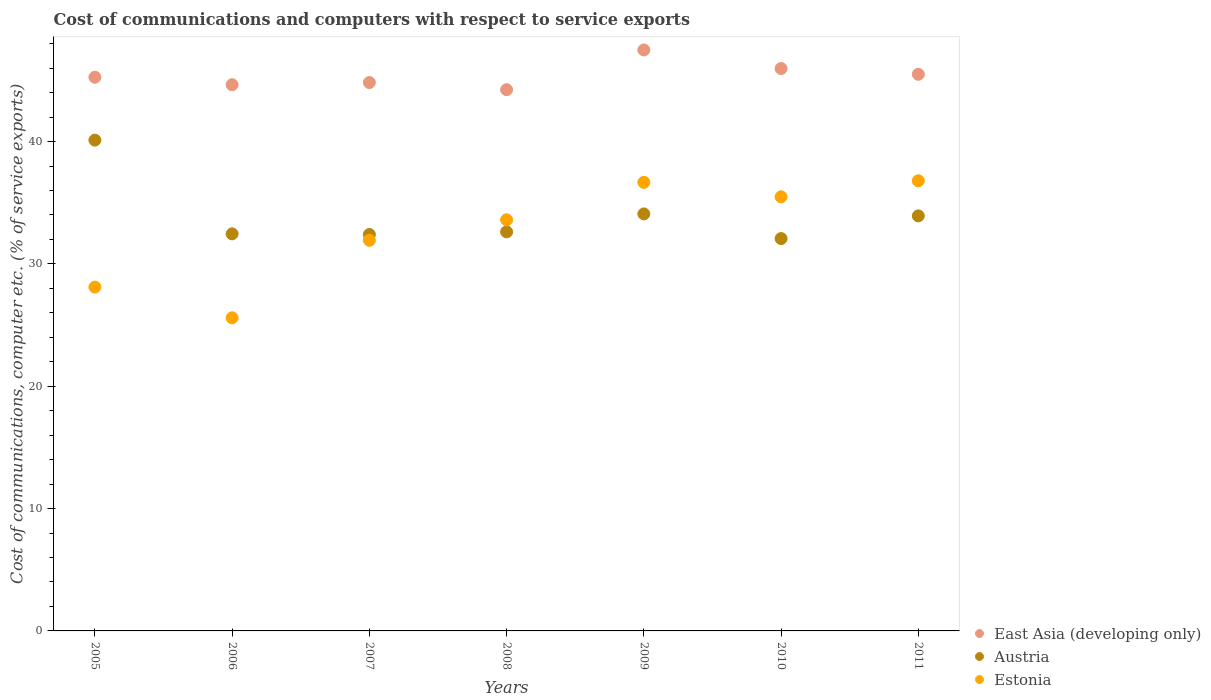How many different coloured dotlines are there?
Keep it short and to the point. 3. What is the cost of communications and computers in East Asia (developing only) in 2006?
Make the answer very short. 44.65. Across all years, what is the maximum cost of communications and computers in East Asia (developing only)?
Offer a terse response. 47.49. Across all years, what is the minimum cost of communications and computers in East Asia (developing only)?
Ensure brevity in your answer.  44.24. In which year was the cost of communications and computers in Estonia minimum?
Offer a terse response. 2006. What is the total cost of communications and computers in Estonia in the graph?
Provide a short and direct response. 228.19. What is the difference between the cost of communications and computers in Austria in 2006 and that in 2010?
Your response must be concise. 0.39. What is the difference between the cost of communications and computers in East Asia (developing only) in 2010 and the cost of communications and computers in Austria in 2007?
Your answer should be compact. 13.56. What is the average cost of communications and computers in Estonia per year?
Provide a short and direct response. 32.6. In the year 2010, what is the difference between the cost of communications and computers in East Asia (developing only) and cost of communications and computers in Estonia?
Make the answer very short. 10.49. In how many years, is the cost of communications and computers in Estonia greater than 18 %?
Your answer should be very brief. 7. What is the ratio of the cost of communications and computers in East Asia (developing only) in 2007 to that in 2010?
Ensure brevity in your answer.  0.98. Is the cost of communications and computers in Austria in 2006 less than that in 2007?
Ensure brevity in your answer.  No. Is the difference between the cost of communications and computers in East Asia (developing only) in 2008 and 2009 greater than the difference between the cost of communications and computers in Estonia in 2008 and 2009?
Your response must be concise. No. What is the difference between the highest and the second highest cost of communications and computers in East Asia (developing only)?
Your answer should be very brief. 1.52. What is the difference between the highest and the lowest cost of communications and computers in Estonia?
Your response must be concise. 11.2. Is the cost of communications and computers in Estonia strictly less than the cost of communications and computers in East Asia (developing only) over the years?
Your answer should be compact. Yes. How many dotlines are there?
Ensure brevity in your answer.  3. How many years are there in the graph?
Keep it short and to the point. 7. What is the difference between two consecutive major ticks on the Y-axis?
Your response must be concise. 10. How many legend labels are there?
Your answer should be very brief. 3. How are the legend labels stacked?
Provide a succinct answer. Vertical. What is the title of the graph?
Keep it short and to the point. Cost of communications and computers with respect to service exports. What is the label or title of the Y-axis?
Give a very brief answer. Cost of communications, computer etc. (% of service exports). What is the Cost of communications, computer etc. (% of service exports) of East Asia (developing only) in 2005?
Keep it short and to the point. 45.26. What is the Cost of communications, computer etc. (% of service exports) in Austria in 2005?
Provide a short and direct response. 40.12. What is the Cost of communications, computer etc. (% of service exports) of Estonia in 2005?
Offer a terse response. 28.11. What is the Cost of communications, computer etc. (% of service exports) of East Asia (developing only) in 2006?
Offer a terse response. 44.65. What is the Cost of communications, computer etc. (% of service exports) in Austria in 2006?
Keep it short and to the point. 32.46. What is the Cost of communications, computer etc. (% of service exports) of Estonia in 2006?
Offer a very short reply. 25.59. What is the Cost of communications, computer etc. (% of service exports) in East Asia (developing only) in 2007?
Your answer should be very brief. 44.83. What is the Cost of communications, computer etc. (% of service exports) of Austria in 2007?
Provide a short and direct response. 32.41. What is the Cost of communications, computer etc. (% of service exports) in Estonia in 2007?
Offer a terse response. 31.93. What is the Cost of communications, computer etc. (% of service exports) in East Asia (developing only) in 2008?
Provide a succinct answer. 44.24. What is the Cost of communications, computer etc. (% of service exports) in Austria in 2008?
Offer a very short reply. 32.62. What is the Cost of communications, computer etc. (% of service exports) in Estonia in 2008?
Provide a short and direct response. 33.61. What is the Cost of communications, computer etc. (% of service exports) of East Asia (developing only) in 2009?
Offer a terse response. 47.49. What is the Cost of communications, computer etc. (% of service exports) in Austria in 2009?
Ensure brevity in your answer.  34.09. What is the Cost of communications, computer etc. (% of service exports) of Estonia in 2009?
Your answer should be compact. 36.67. What is the Cost of communications, computer etc. (% of service exports) of East Asia (developing only) in 2010?
Provide a short and direct response. 45.97. What is the Cost of communications, computer etc. (% of service exports) in Austria in 2010?
Offer a terse response. 32.07. What is the Cost of communications, computer etc. (% of service exports) in Estonia in 2010?
Your answer should be very brief. 35.49. What is the Cost of communications, computer etc. (% of service exports) in East Asia (developing only) in 2011?
Your answer should be compact. 45.5. What is the Cost of communications, computer etc. (% of service exports) of Austria in 2011?
Keep it short and to the point. 33.93. What is the Cost of communications, computer etc. (% of service exports) in Estonia in 2011?
Ensure brevity in your answer.  36.8. Across all years, what is the maximum Cost of communications, computer etc. (% of service exports) in East Asia (developing only)?
Keep it short and to the point. 47.49. Across all years, what is the maximum Cost of communications, computer etc. (% of service exports) in Austria?
Provide a succinct answer. 40.12. Across all years, what is the maximum Cost of communications, computer etc. (% of service exports) of Estonia?
Keep it short and to the point. 36.8. Across all years, what is the minimum Cost of communications, computer etc. (% of service exports) of East Asia (developing only)?
Offer a terse response. 44.24. Across all years, what is the minimum Cost of communications, computer etc. (% of service exports) of Austria?
Provide a short and direct response. 32.07. Across all years, what is the minimum Cost of communications, computer etc. (% of service exports) in Estonia?
Give a very brief answer. 25.59. What is the total Cost of communications, computer etc. (% of service exports) in East Asia (developing only) in the graph?
Provide a short and direct response. 317.95. What is the total Cost of communications, computer etc. (% of service exports) of Austria in the graph?
Make the answer very short. 237.69. What is the total Cost of communications, computer etc. (% of service exports) in Estonia in the graph?
Ensure brevity in your answer.  228.19. What is the difference between the Cost of communications, computer etc. (% of service exports) of East Asia (developing only) in 2005 and that in 2006?
Ensure brevity in your answer.  0.61. What is the difference between the Cost of communications, computer etc. (% of service exports) of Austria in 2005 and that in 2006?
Your answer should be compact. 7.66. What is the difference between the Cost of communications, computer etc. (% of service exports) in Estonia in 2005 and that in 2006?
Offer a terse response. 2.51. What is the difference between the Cost of communications, computer etc. (% of service exports) in East Asia (developing only) in 2005 and that in 2007?
Provide a succinct answer. 0.44. What is the difference between the Cost of communications, computer etc. (% of service exports) in Austria in 2005 and that in 2007?
Ensure brevity in your answer.  7.71. What is the difference between the Cost of communications, computer etc. (% of service exports) of Estonia in 2005 and that in 2007?
Offer a terse response. -3.83. What is the difference between the Cost of communications, computer etc. (% of service exports) in East Asia (developing only) in 2005 and that in 2008?
Offer a terse response. 1.02. What is the difference between the Cost of communications, computer etc. (% of service exports) of Austria in 2005 and that in 2008?
Give a very brief answer. 7.5. What is the difference between the Cost of communications, computer etc. (% of service exports) of Estonia in 2005 and that in 2008?
Your answer should be very brief. -5.5. What is the difference between the Cost of communications, computer etc. (% of service exports) in East Asia (developing only) in 2005 and that in 2009?
Your answer should be compact. -2.23. What is the difference between the Cost of communications, computer etc. (% of service exports) in Austria in 2005 and that in 2009?
Your response must be concise. 6.03. What is the difference between the Cost of communications, computer etc. (% of service exports) of Estonia in 2005 and that in 2009?
Offer a very short reply. -8.56. What is the difference between the Cost of communications, computer etc. (% of service exports) in East Asia (developing only) in 2005 and that in 2010?
Your answer should be compact. -0.71. What is the difference between the Cost of communications, computer etc. (% of service exports) in Austria in 2005 and that in 2010?
Provide a short and direct response. 8.05. What is the difference between the Cost of communications, computer etc. (% of service exports) in Estonia in 2005 and that in 2010?
Your response must be concise. -7.38. What is the difference between the Cost of communications, computer etc. (% of service exports) in East Asia (developing only) in 2005 and that in 2011?
Give a very brief answer. -0.24. What is the difference between the Cost of communications, computer etc. (% of service exports) of Austria in 2005 and that in 2011?
Offer a very short reply. 6.19. What is the difference between the Cost of communications, computer etc. (% of service exports) of Estonia in 2005 and that in 2011?
Provide a short and direct response. -8.69. What is the difference between the Cost of communications, computer etc. (% of service exports) in East Asia (developing only) in 2006 and that in 2007?
Make the answer very short. -0.18. What is the difference between the Cost of communications, computer etc. (% of service exports) of Austria in 2006 and that in 2007?
Your answer should be very brief. 0.05. What is the difference between the Cost of communications, computer etc. (% of service exports) of Estonia in 2006 and that in 2007?
Your answer should be very brief. -6.34. What is the difference between the Cost of communications, computer etc. (% of service exports) in East Asia (developing only) in 2006 and that in 2008?
Your answer should be very brief. 0.41. What is the difference between the Cost of communications, computer etc. (% of service exports) of Austria in 2006 and that in 2008?
Offer a very short reply. -0.16. What is the difference between the Cost of communications, computer etc. (% of service exports) of Estonia in 2006 and that in 2008?
Keep it short and to the point. -8.02. What is the difference between the Cost of communications, computer etc. (% of service exports) of East Asia (developing only) in 2006 and that in 2009?
Offer a very short reply. -2.84. What is the difference between the Cost of communications, computer etc. (% of service exports) of Austria in 2006 and that in 2009?
Give a very brief answer. -1.63. What is the difference between the Cost of communications, computer etc. (% of service exports) in Estonia in 2006 and that in 2009?
Keep it short and to the point. -11.07. What is the difference between the Cost of communications, computer etc. (% of service exports) in East Asia (developing only) in 2006 and that in 2010?
Offer a terse response. -1.32. What is the difference between the Cost of communications, computer etc. (% of service exports) of Austria in 2006 and that in 2010?
Offer a terse response. 0.39. What is the difference between the Cost of communications, computer etc. (% of service exports) in Estonia in 2006 and that in 2010?
Offer a very short reply. -9.89. What is the difference between the Cost of communications, computer etc. (% of service exports) in East Asia (developing only) in 2006 and that in 2011?
Ensure brevity in your answer.  -0.85. What is the difference between the Cost of communications, computer etc. (% of service exports) in Austria in 2006 and that in 2011?
Offer a terse response. -1.47. What is the difference between the Cost of communications, computer etc. (% of service exports) in Estonia in 2006 and that in 2011?
Your response must be concise. -11.2. What is the difference between the Cost of communications, computer etc. (% of service exports) of East Asia (developing only) in 2007 and that in 2008?
Provide a succinct answer. 0.58. What is the difference between the Cost of communications, computer etc. (% of service exports) of Austria in 2007 and that in 2008?
Your response must be concise. -0.21. What is the difference between the Cost of communications, computer etc. (% of service exports) of Estonia in 2007 and that in 2008?
Offer a terse response. -1.68. What is the difference between the Cost of communications, computer etc. (% of service exports) in East Asia (developing only) in 2007 and that in 2009?
Keep it short and to the point. -2.66. What is the difference between the Cost of communications, computer etc. (% of service exports) in Austria in 2007 and that in 2009?
Give a very brief answer. -1.68. What is the difference between the Cost of communications, computer etc. (% of service exports) in Estonia in 2007 and that in 2009?
Keep it short and to the point. -4.73. What is the difference between the Cost of communications, computer etc. (% of service exports) in East Asia (developing only) in 2007 and that in 2010?
Give a very brief answer. -1.14. What is the difference between the Cost of communications, computer etc. (% of service exports) of Austria in 2007 and that in 2010?
Provide a succinct answer. 0.34. What is the difference between the Cost of communications, computer etc. (% of service exports) in Estonia in 2007 and that in 2010?
Provide a short and direct response. -3.55. What is the difference between the Cost of communications, computer etc. (% of service exports) in East Asia (developing only) in 2007 and that in 2011?
Make the answer very short. -0.67. What is the difference between the Cost of communications, computer etc. (% of service exports) in Austria in 2007 and that in 2011?
Provide a short and direct response. -1.52. What is the difference between the Cost of communications, computer etc. (% of service exports) in Estonia in 2007 and that in 2011?
Make the answer very short. -4.86. What is the difference between the Cost of communications, computer etc. (% of service exports) of East Asia (developing only) in 2008 and that in 2009?
Provide a short and direct response. -3.25. What is the difference between the Cost of communications, computer etc. (% of service exports) of Austria in 2008 and that in 2009?
Provide a short and direct response. -1.47. What is the difference between the Cost of communications, computer etc. (% of service exports) of Estonia in 2008 and that in 2009?
Offer a terse response. -3.06. What is the difference between the Cost of communications, computer etc. (% of service exports) of East Asia (developing only) in 2008 and that in 2010?
Give a very brief answer. -1.73. What is the difference between the Cost of communications, computer etc. (% of service exports) in Austria in 2008 and that in 2010?
Ensure brevity in your answer.  0.55. What is the difference between the Cost of communications, computer etc. (% of service exports) in Estonia in 2008 and that in 2010?
Offer a very short reply. -1.88. What is the difference between the Cost of communications, computer etc. (% of service exports) in East Asia (developing only) in 2008 and that in 2011?
Make the answer very short. -1.26. What is the difference between the Cost of communications, computer etc. (% of service exports) in Austria in 2008 and that in 2011?
Your response must be concise. -1.31. What is the difference between the Cost of communications, computer etc. (% of service exports) in Estonia in 2008 and that in 2011?
Your answer should be very brief. -3.19. What is the difference between the Cost of communications, computer etc. (% of service exports) of East Asia (developing only) in 2009 and that in 2010?
Provide a short and direct response. 1.52. What is the difference between the Cost of communications, computer etc. (% of service exports) of Austria in 2009 and that in 2010?
Offer a terse response. 2.02. What is the difference between the Cost of communications, computer etc. (% of service exports) of Estonia in 2009 and that in 2010?
Provide a succinct answer. 1.18. What is the difference between the Cost of communications, computer etc. (% of service exports) in East Asia (developing only) in 2009 and that in 2011?
Keep it short and to the point. 1.99. What is the difference between the Cost of communications, computer etc. (% of service exports) of Austria in 2009 and that in 2011?
Offer a very short reply. 0.16. What is the difference between the Cost of communications, computer etc. (% of service exports) of Estonia in 2009 and that in 2011?
Give a very brief answer. -0.13. What is the difference between the Cost of communications, computer etc. (% of service exports) of East Asia (developing only) in 2010 and that in 2011?
Offer a terse response. 0.47. What is the difference between the Cost of communications, computer etc. (% of service exports) in Austria in 2010 and that in 2011?
Offer a terse response. -1.86. What is the difference between the Cost of communications, computer etc. (% of service exports) of Estonia in 2010 and that in 2011?
Provide a succinct answer. -1.31. What is the difference between the Cost of communications, computer etc. (% of service exports) of East Asia (developing only) in 2005 and the Cost of communications, computer etc. (% of service exports) of Austria in 2006?
Give a very brief answer. 12.8. What is the difference between the Cost of communications, computer etc. (% of service exports) of East Asia (developing only) in 2005 and the Cost of communications, computer etc. (% of service exports) of Estonia in 2006?
Keep it short and to the point. 19.67. What is the difference between the Cost of communications, computer etc. (% of service exports) in Austria in 2005 and the Cost of communications, computer etc. (% of service exports) in Estonia in 2006?
Keep it short and to the point. 14.53. What is the difference between the Cost of communications, computer etc. (% of service exports) of East Asia (developing only) in 2005 and the Cost of communications, computer etc. (% of service exports) of Austria in 2007?
Offer a very short reply. 12.86. What is the difference between the Cost of communications, computer etc. (% of service exports) of East Asia (developing only) in 2005 and the Cost of communications, computer etc. (% of service exports) of Estonia in 2007?
Your answer should be compact. 13.33. What is the difference between the Cost of communications, computer etc. (% of service exports) in Austria in 2005 and the Cost of communications, computer etc. (% of service exports) in Estonia in 2007?
Keep it short and to the point. 8.19. What is the difference between the Cost of communications, computer etc. (% of service exports) in East Asia (developing only) in 2005 and the Cost of communications, computer etc. (% of service exports) in Austria in 2008?
Ensure brevity in your answer.  12.64. What is the difference between the Cost of communications, computer etc. (% of service exports) in East Asia (developing only) in 2005 and the Cost of communications, computer etc. (% of service exports) in Estonia in 2008?
Your answer should be compact. 11.65. What is the difference between the Cost of communications, computer etc. (% of service exports) in Austria in 2005 and the Cost of communications, computer etc. (% of service exports) in Estonia in 2008?
Provide a short and direct response. 6.51. What is the difference between the Cost of communications, computer etc. (% of service exports) of East Asia (developing only) in 2005 and the Cost of communications, computer etc. (% of service exports) of Austria in 2009?
Your answer should be very brief. 11.17. What is the difference between the Cost of communications, computer etc. (% of service exports) of East Asia (developing only) in 2005 and the Cost of communications, computer etc. (% of service exports) of Estonia in 2009?
Give a very brief answer. 8.6. What is the difference between the Cost of communications, computer etc. (% of service exports) in Austria in 2005 and the Cost of communications, computer etc. (% of service exports) in Estonia in 2009?
Keep it short and to the point. 3.45. What is the difference between the Cost of communications, computer etc. (% of service exports) of East Asia (developing only) in 2005 and the Cost of communications, computer etc. (% of service exports) of Austria in 2010?
Your response must be concise. 13.19. What is the difference between the Cost of communications, computer etc. (% of service exports) of East Asia (developing only) in 2005 and the Cost of communications, computer etc. (% of service exports) of Estonia in 2010?
Ensure brevity in your answer.  9.78. What is the difference between the Cost of communications, computer etc. (% of service exports) of Austria in 2005 and the Cost of communications, computer etc. (% of service exports) of Estonia in 2010?
Offer a very short reply. 4.63. What is the difference between the Cost of communications, computer etc. (% of service exports) in East Asia (developing only) in 2005 and the Cost of communications, computer etc. (% of service exports) in Austria in 2011?
Offer a terse response. 11.34. What is the difference between the Cost of communications, computer etc. (% of service exports) of East Asia (developing only) in 2005 and the Cost of communications, computer etc. (% of service exports) of Estonia in 2011?
Ensure brevity in your answer.  8.47. What is the difference between the Cost of communications, computer etc. (% of service exports) of Austria in 2005 and the Cost of communications, computer etc. (% of service exports) of Estonia in 2011?
Provide a short and direct response. 3.32. What is the difference between the Cost of communications, computer etc. (% of service exports) in East Asia (developing only) in 2006 and the Cost of communications, computer etc. (% of service exports) in Austria in 2007?
Your response must be concise. 12.24. What is the difference between the Cost of communications, computer etc. (% of service exports) in East Asia (developing only) in 2006 and the Cost of communications, computer etc. (% of service exports) in Estonia in 2007?
Make the answer very short. 12.72. What is the difference between the Cost of communications, computer etc. (% of service exports) of Austria in 2006 and the Cost of communications, computer etc. (% of service exports) of Estonia in 2007?
Offer a terse response. 0.53. What is the difference between the Cost of communications, computer etc. (% of service exports) in East Asia (developing only) in 2006 and the Cost of communications, computer etc. (% of service exports) in Austria in 2008?
Your response must be concise. 12.03. What is the difference between the Cost of communications, computer etc. (% of service exports) of East Asia (developing only) in 2006 and the Cost of communications, computer etc. (% of service exports) of Estonia in 2008?
Keep it short and to the point. 11.04. What is the difference between the Cost of communications, computer etc. (% of service exports) of Austria in 2006 and the Cost of communications, computer etc. (% of service exports) of Estonia in 2008?
Ensure brevity in your answer.  -1.15. What is the difference between the Cost of communications, computer etc. (% of service exports) in East Asia (developing only) in 2006 and the Cost of communications, computer etc. (% of service exports) in Austria in 2009?
Your response must be concise. 10.56. What is the difference between the Cost of communications, computer etc. (% of service exports) of East Asia (developing only) in 2006 and the Cost of communications, computer etc. (% of service exports) of Estonia in 2009?
Provide a short and direct response. 7.98. What is the difference between the Cost of communications, computer etc. (% of service exports) of Austria in 2006 and the Cost of communications, computer etc. (% of service exports) of Estonia in 2009?
Offer a very short reply. -4.21. What is the difference between the Cost of communications, computer etc. (% of service exports) of East Asia (developing only) in 2006 and the Cost of communications, computer etc. (% of service exports) of Austria in 2010?
Keep it short and to the point. 12.58. What is the difference between the Cost of communications, computer etc. (% of service exports) in East Asia (developing only) in 2006 and the Cost of communications, computer etc. (% of service exports) in Estonia in 2010?
Your answer should be very brief. 9.16. What is the difference between the Cost of communications, computer etc. (% of service exports) of Austria in 2006 and the Cost of communications, computer etc. (% of service exports) of Estonia in 2010?
Give a very brief answer. -3.03. What is the difference between the Cost of communications, computer etc. (% of service exports) of East Asia (developing only) in 2006 and the Cost of communications, computer etc. (% of service exports) of Austria in 2011?
Your answer should be very brief. 10.72. What is the difference between the Cost of communications, computer etc. (% of service exports) in East Asia (developing only) in 2006 and the Cost of communications, computer etc. (% of service exports) in Estonia in 2011?
Your answer should be very brief. 7.85. What is the difference between the Cost of communications, computer etc. (% of service exports) of Austria in 2006 and the Cost of communications, computer etc. (% of service exports) of Estonia in 2011?
Provide a short and direct response. -4.34. What is the difference between the Cost of communications, computer etc. (% of service exports) of East Asia (developing only) in 2007 and the Cost of communications, computer etc. (% of service exports) of Austria in 2008?
Offer a terse response. 12.21. What is the difference between the Cost of communications, computer etc. (% of service exports) in East Asia (developing only) in 2007 and the Cost of communications, computer etc. (% of service exports) in Estonia in 2008?
Your answer should be compact. 11.22. What is the difference between the Cost of communications, computer etc. (% of service exports) of Austria in 2007 and the Cost of communications, computer etc. (% of service exports) of Estonia in 2008?
Provide a succinct answer. -1.2. What is the difference between the Cost of communications, computer etc. (% of service exports) of East Asia (developing only) in 2007 and the Cost of communications, computer etc. (% of service exports) of Austria in 2009?
Provide a short and direct response. 10.74. What is the difference between the Cost of communications, computer etc. (% of service exports) of East Asia (developing only) in 2007 and the Cost of communications, computer etc. (% of service exports) of Estonia in 2009?
Provide a succinct answer. 8.16. What is the difference between the Cost of communications, computer etc. (% of service exports) of Austria in 2007 and the Cost of communications, computer etc. (% of service exports) of Estonia in 2009?
Your answer should be compact. -4.26. What is the difference between the Cost of communications, computer etc. (% of service exports) of East Asia (developing only) in 2007 and the Cost of communications, computer etc. (% of service exports) of Austria in 2010?
Provide a short and direct response. 12.76. What is the difference between the Cost of communications, computer etc. (% of service exports) in East Asia (developing only) in 2007 and the Cost of communications, computer etc. (% of service exports) in Estonia in 2010?
Make the answer very short. 9.34. What is the difference between the Cost of communications, computer etc. (% of service exports) of Austria in 2007 and the Cost of communications, computer etc. (% of service exports) of Estonia in 2010?
Give a very brief answer. -3.08. What is the difference between the Cost of communications, computer etc. (% of service exports) of East Asia (developing only) in 2007 and the Cost of communications, computer etc. (% of service exports) of Austria in 2011?
Your response must be concise. 10.9. What is the difference between the Cost of communications, computer etc. (% of service exports) of East Asia (developing only) in 2007 and the Cost of communications, computer etc. (% of service exports) of Estonia in 2011?
Provide a short and direct response. 8.03. What is the difference between the Cost of communications, computer etc. (% of service exports) of Austria in 2007 and the Cost of communications, computer etc. (% of service exports) of Estonia in 2011?
Offer a terse response. -4.39. What is the difference between the Cost of communications, computer etc. (% of service exports) of East Asia (developing only) in 2008 and the Cost of communications, computer etc. (% of service exports) of Austria in 2009?
Make the answer very short. 10.16. What is the difference between the Cost of communications, computer etc. (% of service exports) in East Asia (developing only) in 2008 and the Cost of communications, computer etc. (% of service exports) in Estonia in 2009?
Ensure brevity in your answer.  7.58. What is the difference between the Cost of communications, computer etc. (% of service exports) of Austria in 2008 and the Cost of communications, computer etc. (% of service exports) of Estonia in 2009?
Your answer should be compact. -4.05. What is the difference between the Cost of communications, computer etc. (% of service exports) in East Asia (developing only) in 2008 and the Cost of communications, computer etc. (% of service exports) in Austria in 2010?
Keep it short and to the point. 12.17. What is the difference between the Cost of communications, computer etc. (% of service exports) in East Asia (developing only) in 2008 and the Cost of communications, computer etc. (% of service exports) in Estonia in 2010?
Make the answer very short. 8.76. What is the difference between the Cost of communications, computer etc. (% of service exports) in Austria in 2008 and the Cost of communications, computer etc. (% of service exports) in Estonia in 2010?
Give a very brief answer. -2.87. What is the difference between the Cost of communications, computer etc. (% of service exports) of East Asia (developing only) in 2008 and the Cost of communications, computer etc. (% of service exports) of Austria in 2011?
Keep it short and to the point. 10.32. What is the difference between the Cost of communications, computer etc. (% of service exports) of East Asia (developing only) in 2008 and the Cost of communications, computer etc. (% of service exports) of Estonia in 2011?
Ensure brevity in your answer.  7.45. What is the difference between the Cost of communications, computer etc. (% of service exports) of Austria in 2008 and the Cost of communications, computer etc. (% of service exports) of Estonia in 2011?
Give a very brief answer. -4.18. What is the difference between the Cost of communications, computer etc. (% of service exports) of East Asia (developing only) in 2009 and the Cost of communications, computer etc. (% of service exports) of Austria in 2010?
Give a very brief answer. 15.42. What is the difference between the Cost of communications, computer etc. (% of service exports) of East Asia (developing only) in 2009 and the Cost of communications, computer etc. (% of service exports) of Estonia in 2010?
Ensure brevity in your answer.  12. What is the difference between the Cost of communications, computer etc. (% of service exports) of Austria in 2009 and the Cost of communications, computer etc. (% of service exports) of Estonia in 2010?
Your answer should be very brief. -1.4. What is the difference between the Cost of communications, computer etc. (% of service exports) in East Asia (developing only) in 2009 and the Cost of communications, computer etc. (% of service exports) in Austria in 2011?
Keep it short and to the point. 13.56. What is the difference between the Cost of communications, computer etc. (% of service exports) of East Asia (developing only) in 2009 and the Cost of communications, computer etc. (% of service exports) of Estonia in 2011?
Give a very brief answer. 10.69. What is the difference between the Cost of communications, computer etc. (% of service exports) in Austria in 2009 and the Cost of communications, computer etc. (% of service exports) in Estonia in 2011?
Provide a short and direct response. -2.71. What is the difference between the Cost of communications, computer etc. (% of service exports) in East Asia (developing only) in 2010 and the Cost of communications, computer etc. (% of service exports) in Austria in 2011?
Give a very brief answer. 12.05. What is the difference between the Cost of communications, computer etc. (% of service exports) of East Asia (developing only) in 2010 and the Cost of communications, computer etc. (% of service exports) of Estonia in 2011?
Provide a short and direct response. 9.18. What is the difference between the Cost of communications, computer etc. (% of service exports) in Austria in 2010 and the Cost of communications, computer etc. (% of service exports) in Estonia in 2011?
Give a very brief answer. -4.72. What is the average Cost of communications, computer etc. (% of service exports) of East Asia (developing only) per year?
Your answer should be very brief. 45.42. What is the average Cost of communications, computer etc. (% of service exports) in Austria per year?
Your answer should be very brief. 33.96. What is the average Cost of communications, computer etc. (% of service exports) in Estonia per year?
Offer a terse response. 32.6. In the year 2005, what is the difference between the Cost of communications, computer etc. (% of service exports) of East Asia (developing only) and Cost of communications, computer etc. (% of service exports) of Austria?
Your answer should be compact. 5.14. In the year 2005, what is the difference between the Cost of communications, computer etc. (% of service exports) in East Asia (developing only) and Cost of communications, computer etc. (% of service exports) in Estonia?
Your answer should be compact. 17.16. In the year 2005, what is the difference between the Cost of communications, computer etc. (% of service exports) of Austria and Cost of communications, computer etc. (% of service exports) of Estonia?
Your answer should be very brief. 12.01. In the year 2006, what is the difference between the Cost of communications, computer etc. (% of service exports) in East Asia (developing only) and Cost of communications, computer etc. (% of service exports) in Austria?
Keep it short and to the point. 12.19. In the year 2006, what is the difference between the Cost of communications, computer etc. (% of service exports) in East Asia (developing only) and Cost of communications, computer etc. (% of service exports) in Estonia?
Provide a short and direct response. 19.06. In the year 2006, what is the difference between the Cost of communications, computer etc. (% of service exports) in Austria and Cost of communications, computer etc. (% of service exports) in Estonia?
Offer a very short reply. 6.87. In the year 2007, what is the difference between the Cost of communications, computer etc. (% of service exports) in East Asia (developing only) and Cost of communications, computer etc. (% of service exports) in Austria?
Keep it short and to the point. 12.42. In the year 2007, what is the difference between the Cost of communications, computer etc. (% of service exports) in East Asia (developing only) and Cost of communications, computer etc. (% of service exports) in Estonia?
Offer a very short reply. 12.89. In the year 2007, what is the difference between the Cost of communications, computer etc. (% of service exports) in Austria and Cost of communications, computer etc. (% of service exports) in Estonia?
Ensure brevity in your answer.  0.47. In the year 2008, what is the difference between the Cost of communications, computer etc. (% of service exports) in East Asia (developing only) and Cost of communications, computer etc. (% of service exports) in Austria?
Offer a terse response. 11.62. In the year 2008, what is the difference between the Cost of communications, computer etc. (% of service exports) of East Asia (developing only) and Cost of communications, computer etc. (% of service exports) of Estonia?
Keep it short and to the point. 10.63. In the year 2008, what is the difference between the Cost of communications, computer etc. (% of service exports) of Austria and Cost of communications, computer etc. (% of service exports) of Estonia?
Your response must be concise. -0.99. In the year 2009, what is the difference between the Cost of communications, computer etc. (% of service exports) in East Asia (developing only) and Cost of communications, computer etc. (% of service exports) in Austria?
Offer a terse response. 13.4. In the year 2009, what is the difference between the Cost of communications, computer etc. (% of service exports) in East Asia (developing only) and Cost of communications, computer etc. (% of service exports) in Estonia?
Your answer should be very brief. 10.82. In the year 2009, what is the difference between the Cost of communications, computer etc. (% of service exports) of Austria and Cost of communications, computer etc. (% of service exports) of Estonia?
Ensure brevity in your answer.  -2.58. In the year 2010, what is the difference between the Cost of communications, computer etc. (% of service exports) in East Asia (developing only) and Cost of communications, computer etc. (% of service exports) in Austria?
Keep it short and to the point. 13.9. In the year 2010, what is the difference between the Cost of communications, computer etc. (% of service exports) of East Asia (developing only) and Cost of communications, computer etc. (% of service exports) of Estonia?
Keep it short and to the point. 10.49. In the year 2010, what is the difference between the Cost of communications, computer etc. (% of service exports) in Austria and Cost of communications, computer etc. (% of service exports) in Estonia?
Your answer should be very brief. -3.42. In the year 2011, what is the difference between the Cost of communications, computer etc. (% of service exports) in East Asia (developing only) and Cost of communications, computer etc. (% of service exports) in Austria?
Provide a short and direct response. 11.57. In the year 2011, what is the difference between the Cost of communications, computer etc. (% of service exports) in East Asia (developing only) and Cost of communications, computer etc. (% of service exports) in Estonia?
Keep it short and to the point. 8.7. In the year 2011, what is the difference between the Cost of communications, computer etc. (% of service exports) of Austria and Cost of communications, computer etc. (% of service exports) of Estonia?
Provide a succinct answer. -2.87. What is the ratio of the Cost of communications, computer etc. (% of service exports) of East Asia (developing only) in 2005 to that in 2006?
Your response must be concise. 1.01. What is the ratio of the Cost of communications, computer etc. (% of service exports) in Austria in 2005 to that in 2006?
Make the answer very short. 1.24. What is the ratio of the Cost of communications, computer etc. (% of service exports) of Estonia in 2005 to that in 2006?
Keep it short and to the point. 1.1. What is the ratio of the Cost of communications, computer etc. (% of service exports) in East Asia (developing only) in 2005 to that in 2007?
Offer a terse response. 1.01. What is the ratio of the Cost of communications, computer etc. (% of service exports) in Austria in 2005 to that in 2007?
Provide a short and direct response. 1.24. What is the ratio of the Cost of communications, computer etc. (% of service exports) in Estonia in 2005 to that in 2007?
Your answer should be very brief. 0.88. What is the ratio of the Cost of communications, computer etc. (% of service exports) in East Asia (developing only) in 2005 to that in 2008?
Ensure brevity in your answer.  1.02. What is the ratio of the Cost of communications, computer etc. (% of service exports) of Austria in 2005 to that in 2008?
Provide a succinct answer. 1.23. What is the ratio of the Cost of communications, computer etc. (% of service exports) of Estonia in 2005 to that in 2008?
Make the answer very short. 0.84. What is the ratio of the Cost of communications, computer etc. (% of service exports) in East Asia (developing only) in 2005 to that in 2009?
Your answer should be very brief. 0.95. What is the ratio of the Cost of communications, computer etc. (% of service exports) of Austria in 2005 to that in 2009?
Give a very brief answer. 1.18. What is the ratio of the Cost of communications, computer etc. (% of service exports) of Estonia in 2005 to that in 2009?
Keep it short and to the point. 0.77. What is the ratio of the Cost of communications, computer etc. (% of service exports) of East Asia (developing only) in 2005 to that in 2010?
Give a very brief answer. 0.98. What is the ratio of the Cost of communications, computer etc. (% of service exports) in Austria in 2005 to that in 2010?
Your response must be concise. 1.25. What is the ratio of the Cost of communications, computer etc. (% of service exports) in Estonia in 2005 to that in 2010?
Your answer should be very brief. 0.79. What is the ratio of the Cost of communications, computer etc. (% of service exports) in East Asia (developing only) in 2005 to that in 2011?
Provide a short and direct response. 0.99. What is the ratio of the Cost of communications, computer etc. (% of service exports) in Austria in 2005 to that in 2011?
Give a very brief answer. 1.18. What is the ratio of the Cost of communications, computer etc. (% of service exports) of Estonia in 2005 to that in 2011?
Ensure brevity in your answer.  0.76. What is the ratio of the Cost of communications, computer etc. (% of service exports) of East Asia (developing only) in 2006 to that in 2007?
Your response must be concise. 1. What is the ratio of the Cost of communications, computer etc. (% of service exports) in Austria in 2006 to that in 2007?
Keep it short and to the point. 1. What is the ratio of the Cost of communications, computer etc. (% of service exports) in Estonia in 2006 to that in 2007?
Provide a short and direct response. 0.8. What is the ratio of the Cost of communications, computer etc. (% of service exports) in East Asia (developing only) in 2006 to that in 2008?
Your response must be concise. 1.01. What is the ratio of the Cost of communications, computer etc. (% of service exports) in Austria in 2006 to that in 2008?
Make the answer very short. 0.99. What is the ratio of the Cost of communications, computer etc. (% of service exports) of Estonia in 2006 to that in 2008?
Offer a terse response. 0.76. What is the ratio of the Cost of communications, computer etc. (% of service exports) of East Asia (developing only) in 2006 to that in 2009?
Your answer should be compact. 0.94. What is the ratio of the Cost of communications, computer etc. (% of service exports) of Austria in 2006 to that in 2009?
Keep it short and to the point. 0.95. What is the ratio of the Cost of communications, computer etc. (% of service exports) in Estonia in 2006 to that in 2009?
Your response must be concise. 0.7. What is the ratio of the Cost of communications, computer etc. (% of service exports) of East Asia (developing only) in 2006 to that in 2010?
Make the answer very short. 0.97. What is the ratio of the Cost of communications, computer etc. (% of service exports) in Austria in 2006 to that in 2010?
Ensure brevity in your answer.  1.01. What is the ratio of the Cost of communications, computer etc. (% of service exports) in Estonia in 2006 to that in 2010?
Offer a terse response. 0.72. What is the ratio of the Cost of communications, computer etc. (% of service exports) in East Asia (developing only) in 2006 to that in 2011?
Offer a terse response. 0.98. What is the ratio of the Cost of communications, computer etc. (% of service exports) in Austria in 2006 to that in 2011?
Give a very brief answer. 0.96. What is the ratio of the Cost of communications, computer etc. (% of service exports) of Estonia in 2006 to that in 2011?
Keep it short and to the point. 0.7. What is the ratio of the Cost of communications, computer etc. (% of service exports) of East Asia (developing only) in 2007 to that in 2008?
Provide a short and direct response. 1.01. What is the ratio of the Cost of communications, computer etc. (% of service exports) of Austria in 2007 to that in 2008?
Provide a succinct answer. 0.99. What is the ratio of the Cost of communications, computer etc. (% of service exports) in Estonia in 2007 to that in 2008?
Ensure brevity in your answer.  0.95. What is the ratio of the Cost of communications, computer etc. (% of service exports) in East Asia (developing only) in 2007 to that in 2009?
Your response must be concise. 0.94. What is the ratio of the Cost of communications, computer etc. (% of service exports) of Austria in 2007 to that in 2009?
Offer a very short reply. 0.95. What is the ratio of the Cost of communications, computer etc. (% of service exports) in Estonia in 2007 to that in 2009?
Provide a short and direct response. 0.87. What is the ratio of the Cost of communications, computer etc. (% of service exports) of East Asia (developing only) in 2007 to that in 2010?
Your answer should be very brief. 0.98. What is the ratio of the Cost of communications, computer etc. (% of service exports) in Austria in 2007 to that in 2010?
Provide a succinct answer. 1.01. What is the ratio of the Cost of communications, computer etc. (% of service exports) of Estonia in 2007 to that in 2010?
Offer a very short reply. 0.9. What is the ratio of the Cost of communications, computer etc. (% of service exports) of East Asia (developing only) in 2007 to that in 2011?
Your answer should be very brief. 0.99. What is the ratio of the Cost of communications, computer etc. (% of service exports) of Austria in 2007 to that in 2011?
Offer a very short reply. 0.96. What is the ratio of the Cost of communications, computer etc. (% of service exports) in Estonia in 2007 to that in 2011?
Ensure brevity in your answer.  0.87. What is the ratio of the Cost of communications, computer etc. (% of service exports) in East Asia (developing only) in 2008 to that in 2009?
Offer a terse response. 0.93. What is the ratio of the Cost of communications, computer etc. (% of service exports) in Austria in 2008 to that in 2009?
Your response must be concise. 0.96. What is the ratio of the Cost of communications, computer etc. (% of service exports) in Estonia in 2008 to that in 2009?
Make the answer very short. 0.92. What is the ratio of the Cost of communications, computer etc. (% of service exports) of East Asia (developing only) in 2008 to that in 2010?
Keep it short and to the point. 0.96. What is the ratio of the Cost of communications, computer etc. (% of service exports) in Austria in 2008 to that in 2010?
Provide a succinct answer. 1.02. What is the ratio of the Cost of communications, computer etc. (% of service exports) in Estonia in 2008 to that in 2010?
Provide a succinct answer. 0.95. What is the ratio of the Cost of communications, computer etc. (% of service exports) in East Asia (developing only) in 2008 to that in 2011?
Ensure brevity in your answer.  0.97. What is the ratio of the Cost of communications, computer etc. (% of service exports) in Austria in 2008 to that in 2011?
Provide a short and direct response. 0.96. What is the ratio of the Cost of communications, computer etc. (% of service exports) of Estonia in 2008 to that in 2011?
Keep it short and to the point. 0.91. What is the ratio of the Cost of communications, computer etc. (% of service exports) of East Asia (developing only) in 2009 to that in 2010?
Ensure brevity in your answer.  1.03. What is the ratio of the Cost of communications, computer etc. (% of service exports) of Austria in 2009 to that in 2010?
Offer a terse response. 1.06. What is the ratio of the Cost of communications, computer etc. (% of service exports) in East Asia (developing only) in 2009 to that in 2011?
Keep it short and to the point. 1.04. What is the ratio of the Cost of communications, computer etc. (% of service exports) of Estonia in 2009 to that in 2011?
Provide a short and direct response. 1. What is the ratio of the Cost of communications, computer etc. (% of service exports) in East Asia (developing only) in 2010 to that in 2011?
Offer a very short reply. 1.01. What is the ratio of the Cost of communications, computer etc. (% of service exports) of Austria in 2010 to that in 2011?
Your answer should be very brief. 0.95. What is the ratio of the Cost of communications, computer etc. (% of service exports) of Estonia in 2010 to that in 2011?
Your answer should be very brief. 0.96. What is the difference between the highest and the second highest Cost of communications, computer etc. (% of service exports) in East Asia (developing only)?
Keep it short and to the point. 1.52. What is the difference between the highest and the second highest Cost of communications, computer etc. (% of service exports) of Austria?
Your response must be concise. 6.03. What is the difference between the highest and the second highest Cost of communications, computer etc. (% of service exports) of Estonia?
Provide a succinct answer. 0.13. What is the difference between the highest and the lowest Cost of communications, computer etc. (% of service exports) in East Asia (developing only)?
Your answer should be very brief. 3.25. What is the difference between the highest and the lowest Cost of communications, computer etc. (% of service exports) of Austria?
Provide a short and direct response. 8.05. What is the difference between the highest and the lowest Cost of communications, computer etc. (% of service exports) in Estonia?
Provide a succinct answer. 11.2. 